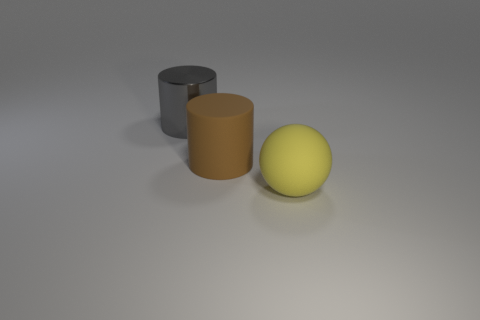Add 1 big red rubber blocks. How many objects exist? 4 Add 2 big yellow objects. How many big yellow objects are left? 3 Add 3 large brown matte objects. How many large brown matte objects exist? 4 Subtract all brown cylinders. How many cylinders are left? 1 Subtract 1 brown cylinders. How many objects are left? 2 Subtract all spheres. How many objects are left? 2 Subtract 2 cylinders. How many cylinders are left? 0 Subtract all blue balls. Subtract all blue cubes. How many balls are left? 1 Subtract all blue blocks. How many purple cylinders are left? 0 Subtract all large yellow balls. Subtract all large brown objects. How many objects are left? 1 